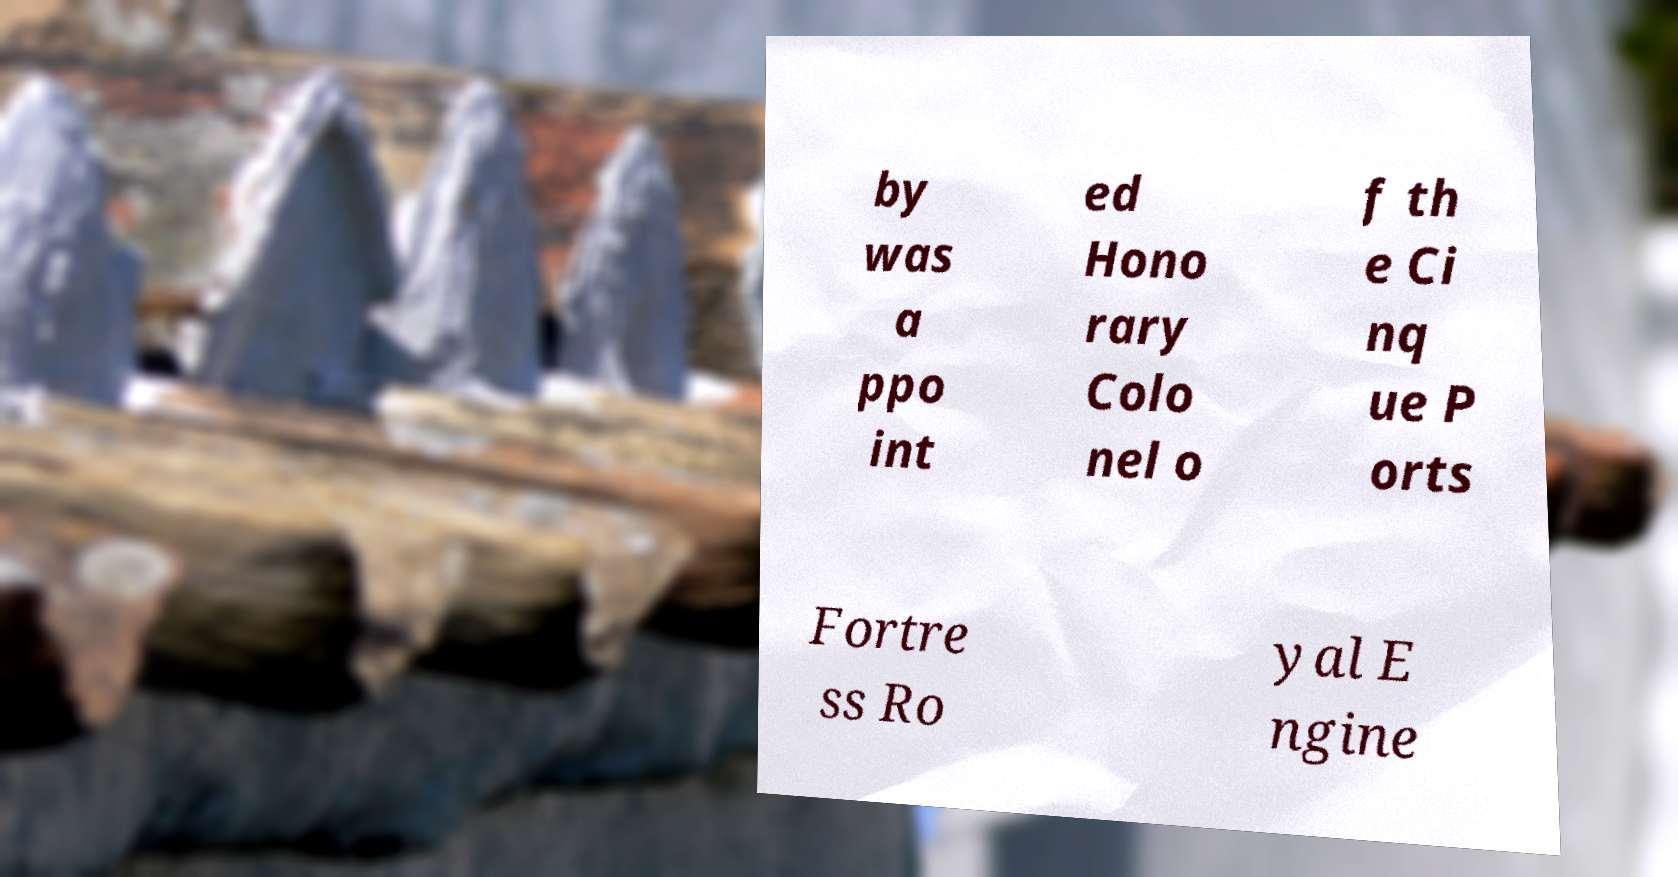There's text embedded in this image that I need extracted. Can you transcribe it verbatim? by was a ppo int ed Hono rary Colo nel o f th e Ci nq ue P orts Fortre ss Ro yal E ngine 